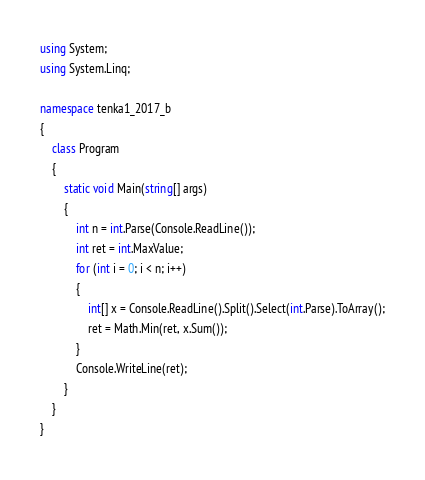Convert code to text. <code><loc_0><loc_0><loc_500><loc_500><_C#_>using System;
using System.Linq;

namespace tenka1_2017_b
{
    class Program
    {
        static void Main(string[] args)
        {
            int n = int.Parse(Console.ReadLine());
            int ret = int.MaxValue;
            for (int i = 0; i < n; i++)
            {
                int[] x = Console.ReadLine().Split().Select(int.Parse).ToArray();
                ret = Math.Min(ret, x.Sum());
            }
            Console.WriteLine(ret);
        }
    }
}</code> 